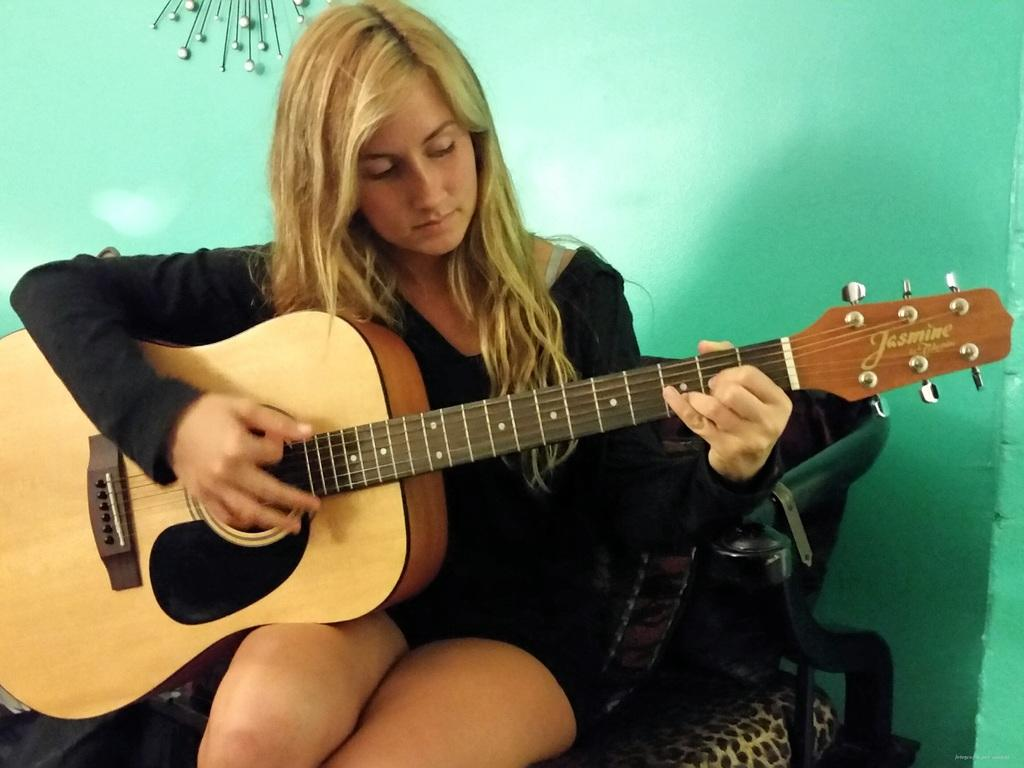What is the woman in the image doing? The woman is playing a guitar in the image. What can be seen in the background of the image? There is a wall in the background of the image. What type of operation is the woman performing on the tramp in the image? There is no tramp or operation present in the image; it features a woman playing a guitar with a wall in the background. 